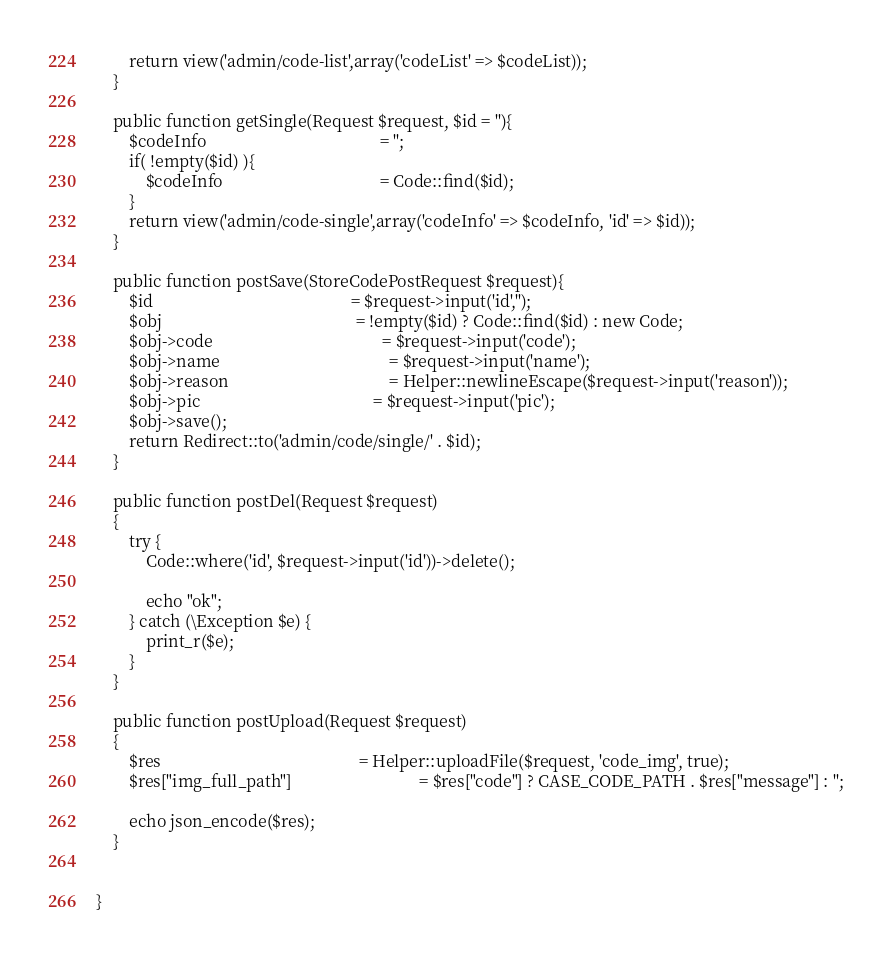Convert code to text. <code><loc_0><loc_0><loc_500><loc_500><_PHP_>		return view('admin/code-list',array('codeList' => $codeList));
	}

	public function getSingle(Request $request, $id = ''){
		$codeInfo                                          = '';
		if( !empty($id) ){
			$codeInfo                                      = Code::find($id);
		}
		return view('admin/code-single',array('codeInfo' => $codeInfo, 'id' => $id));
	}

	public function postSave(StoreCodePostRequest $request){
		$id                                                = $request->input('id','');
		$obj                                               = !empty($id) ? Code::find($id) : new Code;
		$obj->code                                         = $request->input('code');
		$obj->name                                         = $request->input('name');
		$obj->reason                                       = Helper::newlineEscape($request->input('reason'));
		$obj->pic                                          = $request->input('pic');
		$obj->save();
		return Redirect::to('admin/code/single/' . $id);
	}

	public function postDel(Request $request)
	{
		try {
			Code::where('id', $request->input('id'))->delete();
			
			echo "ok";
		} catch (\Exception $e) {
			print_r($e); 
		}
	}

	public function postUpload(Request $request)
	{
		$res 												= Helper::uploadFile($request, 'code_img', true);
		$res["img_full_path"]								= $res["code"] ? CASE_CODE_PATH . $res["message"] : '';
		
		echo json_encode($res);
	}

	
}</code> 